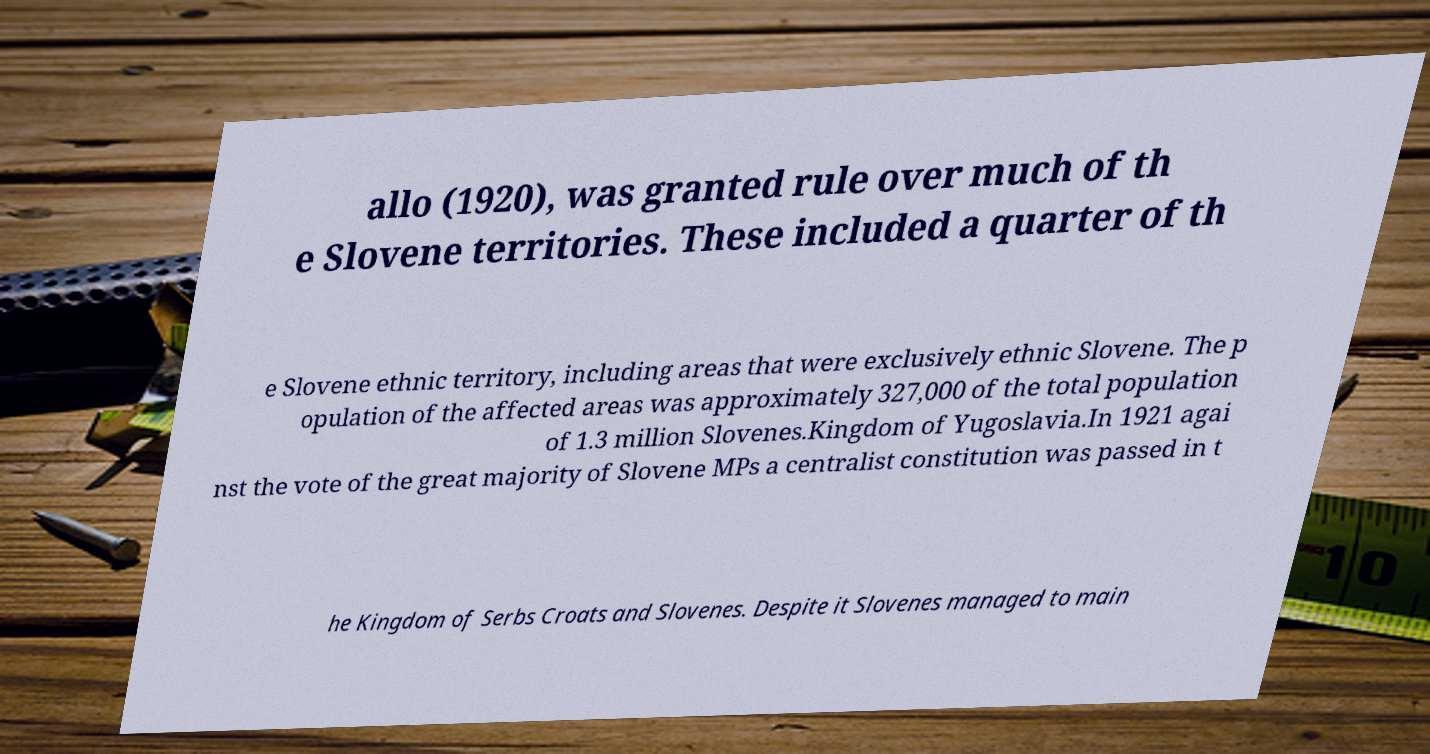There's text embedded in this image that I need extracted. Can you transcribe it verbatim? allo (1920), was granted rule over much of th e Slovene territories. These included a quarter of th e Slovene ethnic territory, including areas that were exclusively ethnic Slovene. The p opulation of the affected areas was approximately 327,000 of the total population of 1.3 million Slovenes.Kingdom of Yugoslavia.In 1921 agai nst the vote of the great majority of Slovene MPs a centralist constitution was passed in t he Kingdom of Serbs Croats and Slovenes. Despite it Slovenes managed to main 